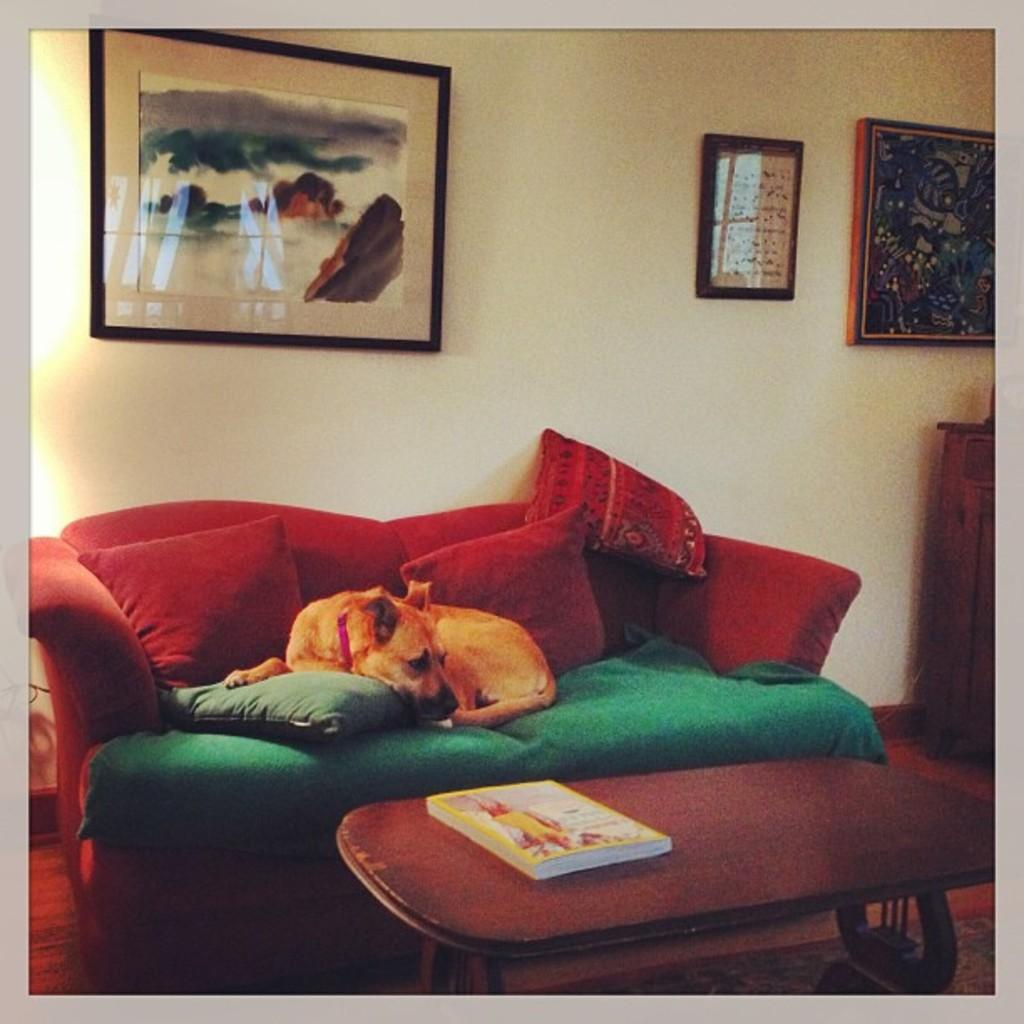What color is the wall that is visible in the image? There is a yellow color wall in the image. What objects can be seen hanging on the wall in the image? There are photo frames in the image. What type of furniture is present in the image? There are sofas in the image. What type of decorative items are on the sofas? There are pillows in the image. What is the small piece of furniture on which a book is placed? There is a small table in the image. What is the book resting on in the image? There is a book on the table in the image. What type of produce is visible on the sofas in the image? There is no produce visible on the sofas in the image. Can you hear the voice of the giraffe in the image? There is no giraffe present in the image, so it cannot have a voice. 